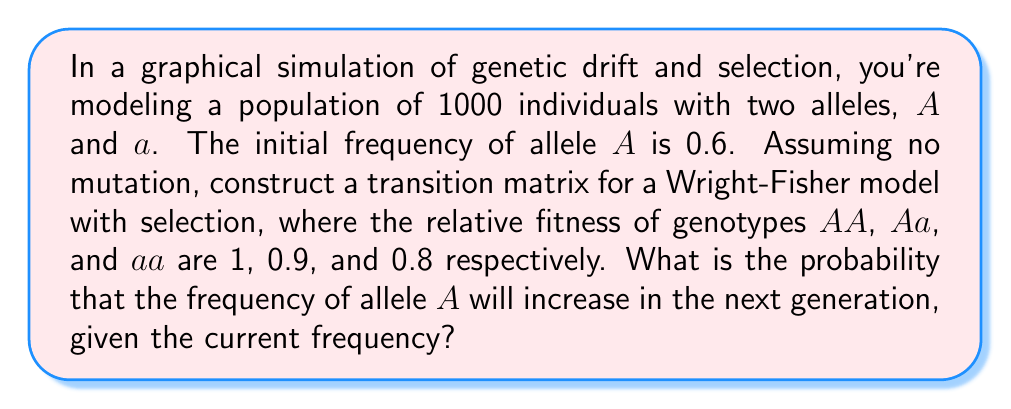What is the answer to this math problem? To solve this problem, we need to follow these steps:

1. Calculate the fitness of each genotype:
   $w_{AA} = 1$, $w_{Aa} = 0.9$, $w_{aa} = 0.8$

2. Calculate the current frequencies of genotypes:
   $f_{AA} = p^2 = 0.6^2 = 0.36$
   $f_{Aa} = 2pq = 2 * 0.6 * 0.4 = 0.48$
   $f_{aa} = q^2 = 0.4^2 = 0.16$

3. Calculate the mean fitness of the population:
   $\bar{w} = w_{AA}f_{AA} + w_{Aa}f_{Aa} + w_{aa}f_{aa}$
   $\bar{w} = 1 * 0.36 + 0.9 * 0.48 + 0.8 * 0.16 = 0.936$

4. Calculate the expected frequency of allele A in the next generation:
   $$p' = \frac{w_{AA}f_{AA} + \frac{1}{2}w_{Aa}f_{Aa}}{\bar{w}}$$
   $$p' = \frac{1 * 0.36 + \frac{1}{2} * 0.9 * 0.48}{0.936} \approx 0.6154$$

5. The probability that the frequency of allele A will increase is equal to the probability that the number of A alleles in the next generation is greater than 600 (since 0.6 * 1000 = 600).

6. We can model this using a binomial distribution with parameters n = 2000 (total number of alleles) and p = 0.6154 (probability of selecting an A allele).

7. The probability is:
   $$P(X > 600) = 1 - P(X \leq 600)$$
   
   Where X follows a Binomial(2000, 0.6154) distribution.

8. Using a normal approximation to the binomial distribution (valid for large n):
   $$\mu = np = 2000 * 0.6154 = 1230.8$$
   $$\sigma = \sqrt{np(1-p)} = \sqrt{2000 * 0.6154 * (1-0.6154)} \approx 21.76$$

9. Standardizing:
   $$z = \frac{600.5 - 1230.8}{21.76} \approx -28.97$$

10. The probability is then:
    $$P(X > 600) = 1 - \Phi(-28.97) \approx 1$$

Where $\Phi$ is the cumulative distribution function of the standard normal distribution.
Answer: The probability that the frequency of allele A will increase in the next generation is approximately 1 (or >0.9999). 